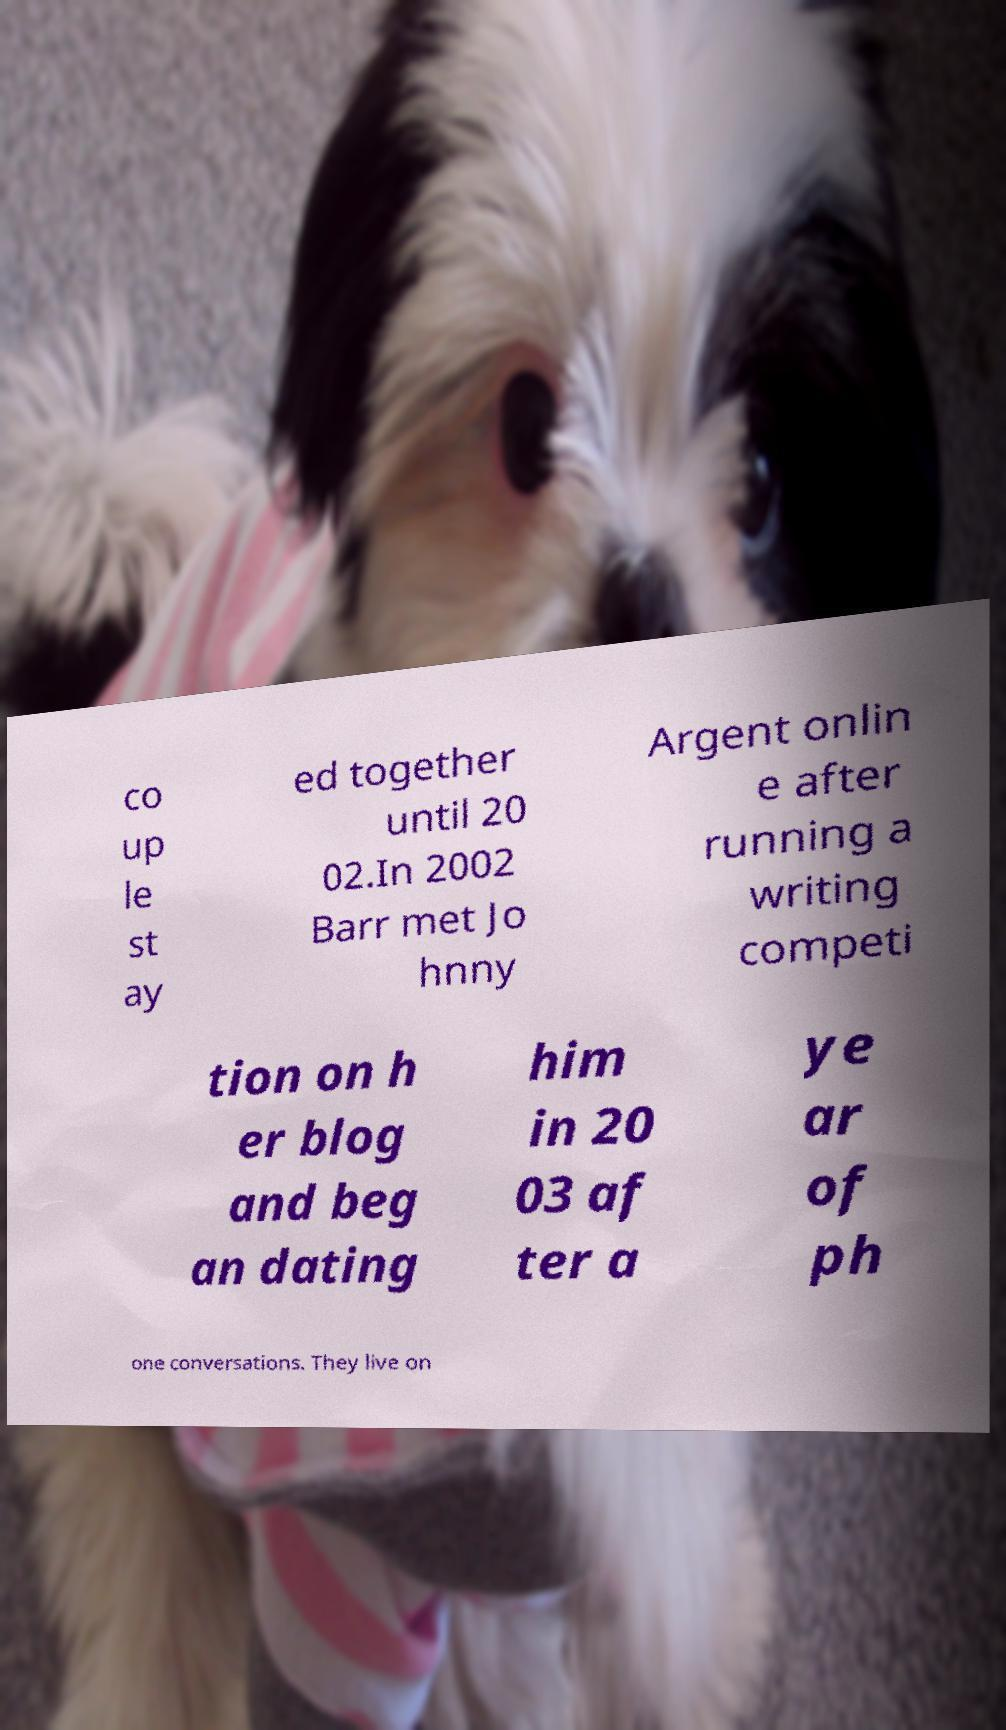Could you assist in decoding the text presented in this image and type it out clearly? co up le st ay ed together until 20 02.In 2002 Barr met Jo hnny Argent onlin e after running a writing competi tion on h er blog and beg an dating him in 20 03 af ter a ye ar of ph one conversations. They live on 